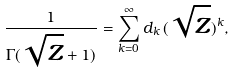<formula> <loc_0><loc_0><loc_500><loc_500>\frac { 1 } { \Gamma ( \sqrt { z } + 1 ) } = \sum _ { k = 0 } ^ { \infty } d _ { k } \, ( \sqrt { z } ) ^ { k } ,</formula> 